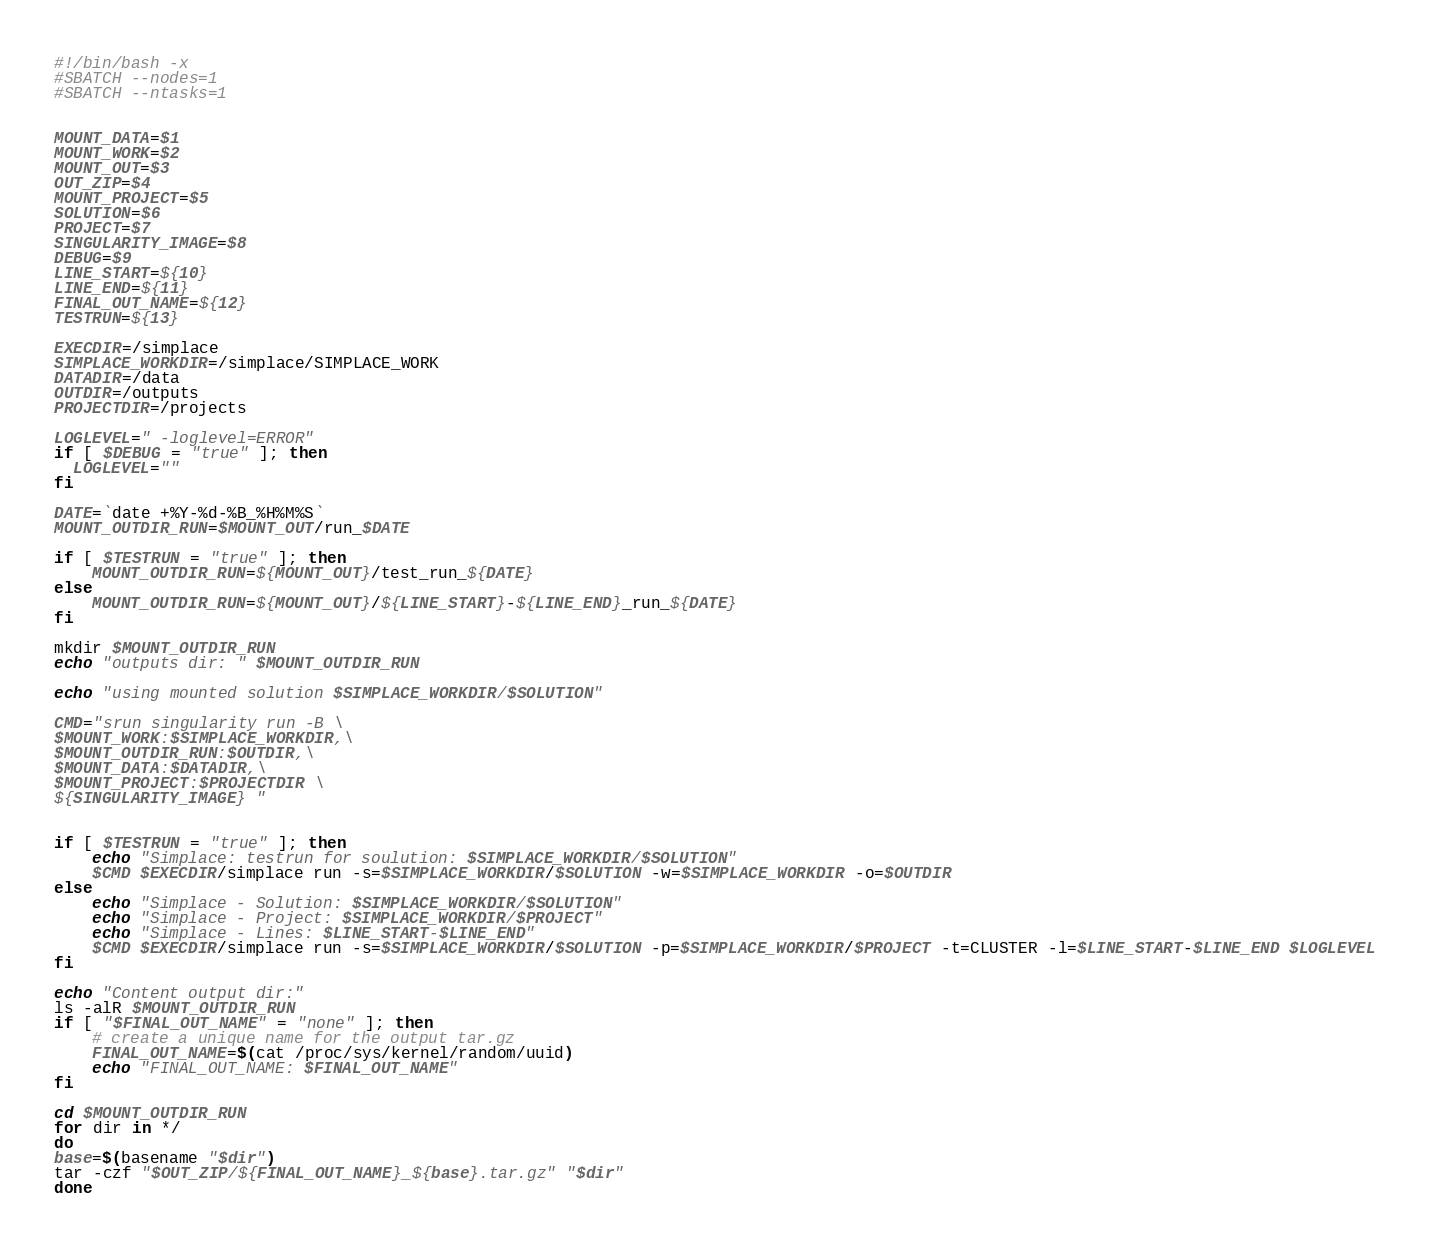Convert code to text. <code><loc_0><loc_0><loc_500><loc_500><_Bash_>#!/bin/bash -x
#SBATCH --nodes=1
#SBATCH --ntasks=1


MOUNT_DATA=$1
MOUNT_WORK=$2
MOUNT_OUT=$3
OUT_ZIP=$4
MOUNT_PROJECT=$5
SOLUTION=$6
PROJECT=$7
SINGULARITY_IMAGE=$8
DEBUG=$9
LINE_START=${10}
LINE_END=${11}
FINAL_OUT_NAME=${12}
TESTRUN=${13}

EXECDIR=/simplace
SIMPLACE_WORKDIR=/simplace/SIMPLACE_WORK
DATADIR=/data
OUTDIR=/outputs
PROJECTDIR=/projects

LOGLEVEL=" -loglevel=ERROR"
if [ $DEBUG = "true" ]; then
  LOGLEVEL=""
fi

DATE=`date +%Y-%d-%B_%H%M%S`
MOUNT_OUTDIR_RUN=$MOUNT_OUT/run_$DATE

if [ $TESTRUN = "true" ]; then
    MOUNT_OUTDIR_RUN=${MOUNT_OUT}/test_run_${DATE}
else 
    MOUNT_OUTDIR_RUN=${MOUNT_OUT}/${LINE_START}-${LINE_END}_run_${DATE}
fi 

mkdir $MOUNT_OUTDIR_RUN
echo "outputs dir: " $MOUNT_OUTDIR_RUN

echo "using mounted solution $SIMPLACE_WORKDIR/$SOLUTION"

CMD="srun singularity run -B \
$MOUNT_WORK:$SIMPLACE_WORKDIR,\
$MOUNT_OUTDIR_RUN:$OUTDIR,\
$MOUNT_DATA:$DATADIR,\
$MOUNT_PROJECT:$PROJECTDIR \
${SINGULARITY_IMAGE} "


if [ $TESTRUN = "true" ]; then
    echo "Simplace: testrun for soulution: $SIMPLACE_WORKDIR/$SOLUTION"
    $CMD $EXECDIR/simplace run -s=$SIMPLACE_WORKDIR/$SOLUTION -w=$SIMPLACE_WORKDIR -o=$OUTDIR
else 
    echo "Simplace - Solution: $SIMPLACE_WORKDIR/$SOLUTION"
    echo "Simplace - Project: $SIMPLACE_WORKDIR/$PROJECT"
    echo "Simplace - Lines: $LINE_START-$LINE_END"
    $CMD $EXECDIR/simplace run -s=$SIMPLACE_WORKDIR/$SOLUTION -p=$SIMPLACE_WORKDIR/$PROJECT -t=CLUSTER -l=$LINE_START-$LINE_END $LOGLEVEL
fi  

echo "Content output dir:"
ls -alR $MOUNT_OUTDIR_RUN
if [ "$FINAL_OUT_NAME" = "none" ]; then
	# create a unique name for the output tar.gz
	FINAL_OUT_NAME=$(cat /proc/sys/kernel/random/uuid)
	echo "FINAL_OUT_NAME: $FINAL_OUT_NAME"
fi 

cd $MOUNT_OUTDIR_RUN
for dir in */
do
base=$(basename "$dir")
tar -czf "$OUT_ZIP/${FINAL_OUT_NAME}_${base}.tar.gz" "$dir"
done
</code> 